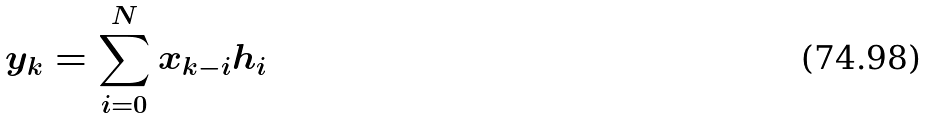Convert formula to latex. <formula><loc_0><loc_0><loc_500><loc_500>y _ { k } = \sum _ { i = 0 } ^ { N } x _ { k - i } h _ { i }</formula> 